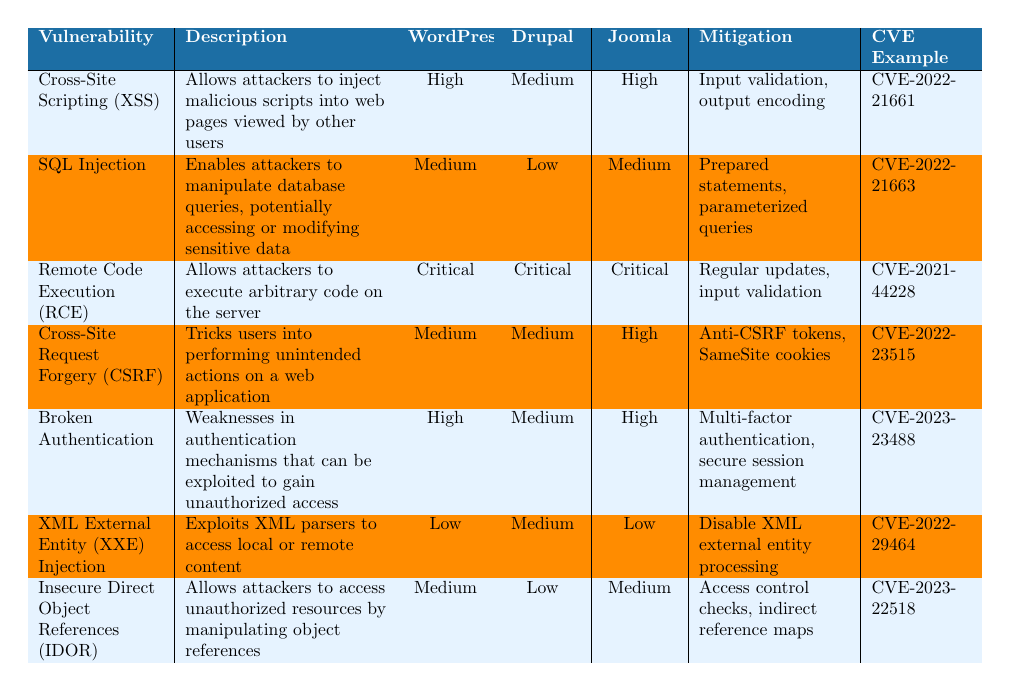What is the impact level of Cross-Site Scripting (XSS) on WordPress? The table indicates that the impact level of Cross-Site Scripting (XSS) on WordPress is "High."
Answer: High Which vulnerability has the highest impact across all content management systems? The table shows that Remote Code Execution (RCE) has a "Critical" impact level for WordPress, Drupal, and Joomla, making it the highest across all systems.
Answer: Remote Code Execution (RCE) Is the impact of SQL Injection on Drupal high or low? According to the table, SQL Injection has a "Low" impact level on Drupal.
Answer: Low How many vulnerabilities have a "Medium" impact on Joomla? By checking the table, we find that Cross-Site Request Forgery (CSRF) and Insecure Direct Object References (IDOR) have a "Medium" impact on Joomla, totaling two vulnerabilities.
Answer: 2 What mitigation strategies are listed for Broken Authentication? The table states that the mitigation strategies for Broken Authentication include "Multi-factor authentication and secure session management."
Answer: Multi-factor authentication, secure session management True or False: XML External Entity (XXE) Injection has a "Critical" impact on WordPress. The table indicates that XML External Entity (XXE) Injection has a "Low" impact on WordPress, making the statement false.
Answer: False Which CMS has the highest impact level for Cross-Site Request Forgery (CSRF)? Looking at the table, Joomla has a "High" impact level for Cross-Site Request Forgery (CSRF), which is higher than WordPress and Drupal.
Answer: Joomla What are the mitigation strategies for vulnerabilities rated as "Critical"? The table lists "Regular updates and input validation" for Remote Code Execution (RCE) as its mitigation strategies. It does not provide mitigation strategies for the overall category but indicates these specific measures.
Answer: Regular updates, input validation If we were to count the vulnerabilities with at least a "Medium" impact level on WordPress, how many would there be? Counting the vulnerabilities, we find Cross-Site Scripting (XSS), Broken Authentication, Remote Code Execution (RCE), and Insecure Direct Object References (IDOR) — a total of four vulnerabilities that have a "Medium" or higher impact on WordPress.
Answer: 4 What is the CVE example for the Insecure Direct Object References vulnerability? The table provides CVE-2023-22518 as the CVE example for Insecure Direct Object References.
Answer: CVE-2023-22518 